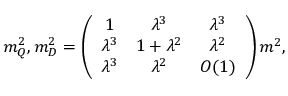<formula> <loc_0><loc_0><loc_500><loc_500>m _ { Q } ^ { 2 } , m _ { D } ^ { 2 } = \left ( \begin{array} { c c c } { 1 } & { { \lambda ^ { 3 } } } & { { \lambda ^ { 3 } } } \\ { { \lambda ^ { 3 } } } & { { 1 + \lambda ^ { 2 } } } & { { \lambda ^ { 2 } } } \\ { { \lambda ^ { 3 } } } & { { \lambda ^ { 2 } } } & { O ( 1 ) } \end{array} \right ) m ^ { 2 } ,</formula> 